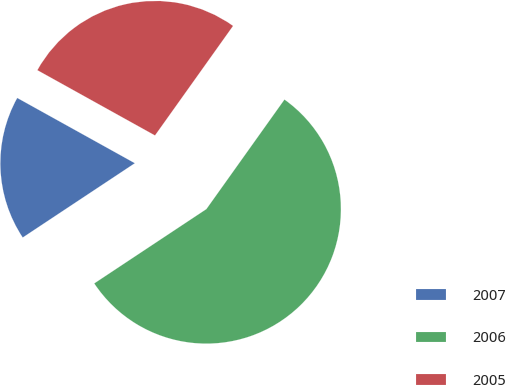Convert chart. <chart><loc_0><loc_0><loc_500><loc_500><pie_chart><fcel>2007<fcel>2006<fcel>2005<nl><fcel>17.38%<fcel>55.83%<fcel>26.79%<nl></chart> 